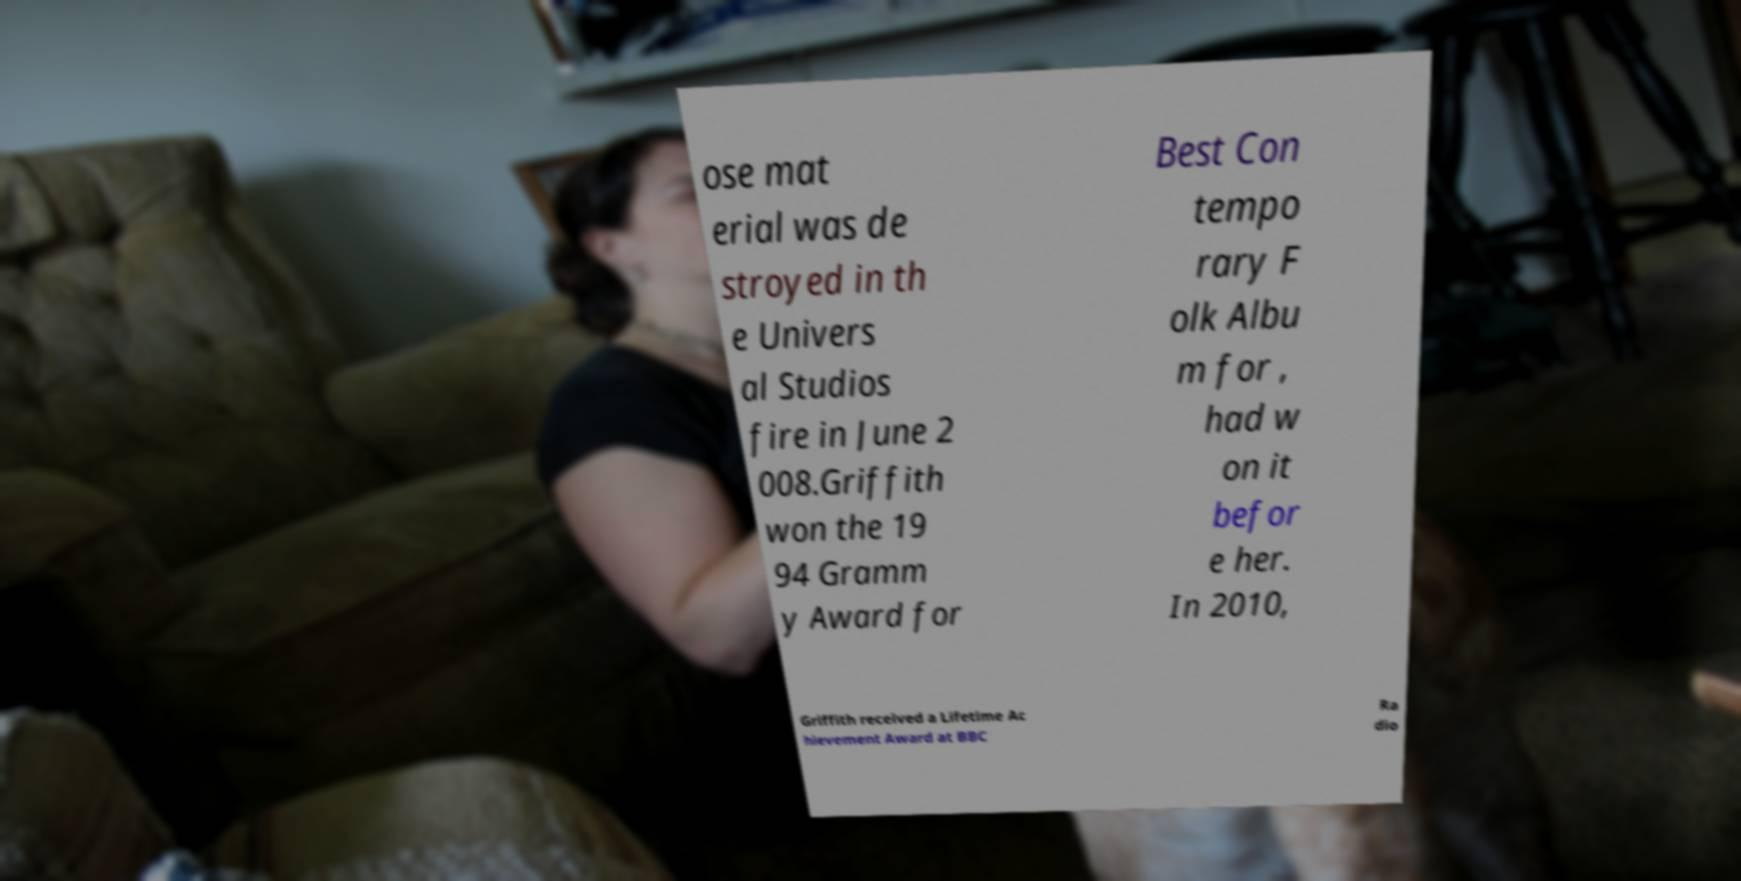Could you assist in decoding the text presented in this image and type it out clearly? ose mat erial was de stroyed in th e Univers al Studios fire in June 2 008.Griffith won the 19 94 Gramm y Award for Best Con tempo rary F olk Albu m for , had w on it befor e her. In 2010, Griffith received a Lifetime Ac hievement Award at BBC Ra dio 